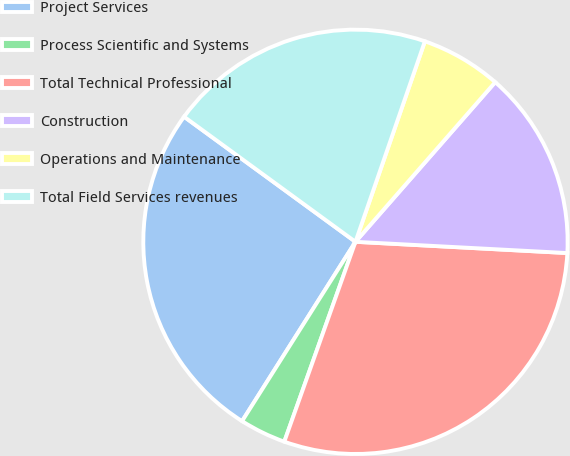<chart> <loc_0><loc_0><loc_500><loc_500><pie_chart><fcel>Project Services<fcel>Process Scientific and Systems<fcel>Total Technical Professional<fcel>Construction<fcel>Operations and Maintenance<fcel>Total Field Services revenues<nl><fcel>26.06%<fcel>3.53%<fcel>29.6%<fcel>14.4%<fcel>6.14%<fcel>20.27%<nl></chart> 